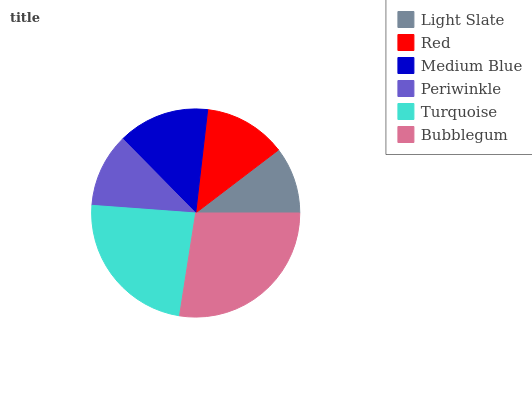Is Light Slate the minimum?
Answer yes or no. Yes. Is Bubblegum the maximum?
Answer yes or no. Yes. Is Red the minimum?
Answer yes or no. No. Is Red the maximum?
Answer yes or no. No. Is Red greater than Light Slate?
Answer yes or no. Yes. Is Light Slate less than Red?
Answer yes or no. Yes. Is Light Slate greater than Red?
Answer yes or no. No. Is Red less than Light Slate?
Answer yes or no. No. Is Medium Blue the high median?
Answer yes or no. Yes. Is Red the low median?
Answer yes or no. Yes. Is Red the high median?
Answer yes or no. No. Is Bubblegum the low median?
Answer yes or no. No. 